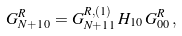<formula> <loc_0><loc_0><loc_500><loc_500>G ^ { R } _ { N + 1 \, 0 } = G ^ { R , ( 1 ) } _ { N + 1 \, 1 } \, H _ { 1 0 } \, G ^ { R } _ { 0 0 } \, ,</formula> 